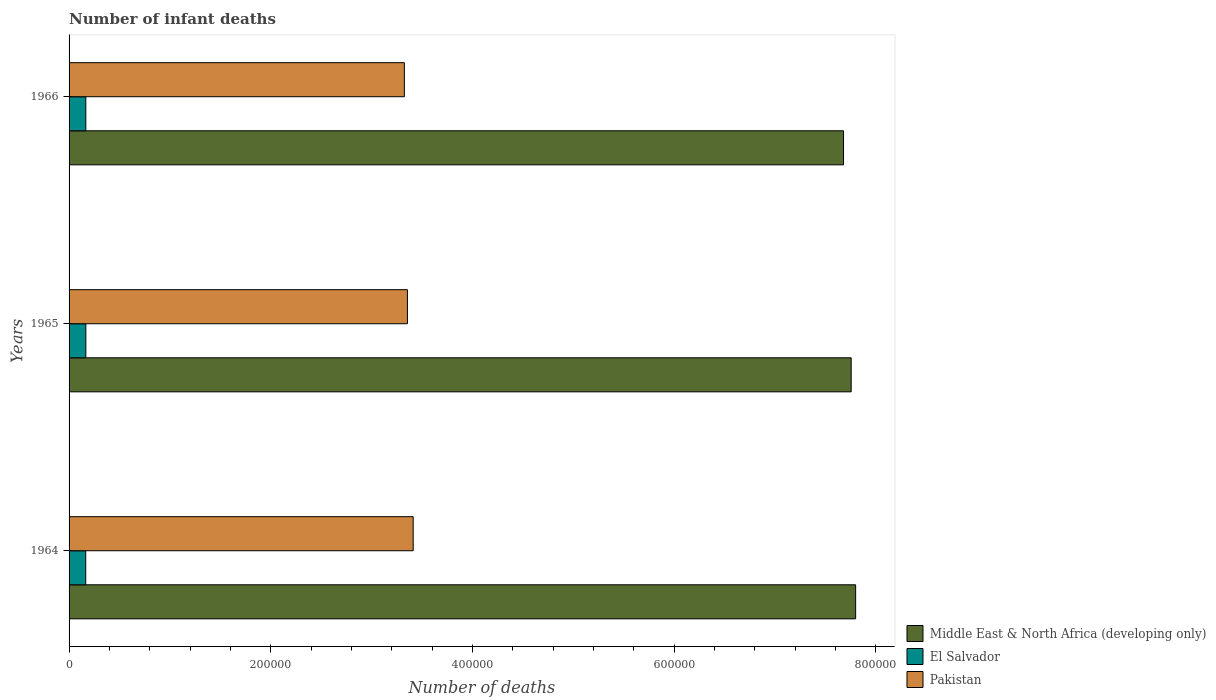How many groups of bars are there?
Give a very brief answer. 3. Are the number of bars per tick equal to the number of legend labels?
Offer a terse response. Yes. How many bars are there on the 2nd tick from the top?
Your answer should be compact. 3. How many bars are there on the 3rd tick from the bottom?
Offer a very short reply. 3. What is the label of the 2nd group of bars from the top?
Provide a short and direct response. 1965. What is the number of infant deaths in Middle East & North Africa (developing only) in 1965?
Ensure brevity in your answer.  7.75e+05. Across all years, what is the maximum number of infant deaths in Middle East & North Africa (developing only)?
Provide a succinct answer. 7.80e+05. Across all years, what is the minimum number of infant deaths in Pakistan?
Your response must be concise. 3.32e+05. In which year was the number of infant deaths in Pakistan maximum?
Make the answer very short. 1964. In which year was the number of infant deaths in El Salvador minimum?
Provide a succinct answer. 1964. What is the total number of infant deaths in Middle East & North Africa (developing only) in the graph?
Give a very brief answer. 2.32e+06. What is the difference between the number of infant deaths in Pakistan in 1965 and that in 1966?
Your answer should be very brief. 3063. What is the difference between the number of infant deaths in Pakistan in 1964 and the number of infant deaths in El Salvador in 1965?
Make the answer very short. 3.25e+05. What is the average number of infant deaths in Pakistan per year?
Provide a short and direct response. 3.36e+05. In the year 1964, what is the difference between the number of infant deaths in Middle East & North Africa (developing only) and number of infant deaths in Pakistan?
Your answer should be very brief. 4.39e+05. What is the ratio of the number of infant deaths in Pakistan in 1964 to that in 1966?
Your answer should be compact. 1.03. Is the difference between the number of infant deaths in Middle East & North Africa (developing only) in 1964 and 1965 greater than the difference between the number of infant deaths in Pakistan in 1964 and 1965?
Your answer should be very brief. No. What is the difference between the highest and the second highest number of infant deaths in Pakistan?
Offer a terse response. 5691. What is the difference between the highest and the lowest number of infant deaths in Pakistan?
Give a very brief answer. 8754. What does the 1st bar from the top in 1966 represents?
Make the answer very short. Pakistan. How many bars are there?
Ensure brevity in your answer.  9. Are all the bars in the graph horizontal?
Your response must be concise. Yes. How many years are there in the graph?
Provide a short and direct response. 3. Does the graph contain any zero values?
Make the answer very short. No. Where does the legend appear in the graph?
Provide a short and direct response. Bottom right. What is the title of the graph?
Provide a succinct answer. Number of infant deaths. Does "Sint Maarten (Dutch part)" appear as one of the legend labels in the graph?
Offer a very short reply. No. What is the label or title of the X-axis?
Your answer should be very brief. Number of deaths. What is the label or title of the Y-axis?
Offer a terse response. Years. What is the Number of deaths of Middle East & North Africa (developing only) in 1964?
Provide a short and direct response. 7.80e+05. What is the Number of deaths in El Salvador in 1964?
Offer a terse response. 1.65e+04. What is the Number of deaths of Pakistan in 1964?
Provide a short and direct response. 3.41e+05. What is the Number of deaths in Middle East & North Africa (developing only) in 1965?
Offer a terse response. 7.75e+05. What is the Number of deaths of El Salvador in 1965?
Your answer should be very brief. 1.66e+04. What is the Number of deaths in Pakistan in 1965?
Give a very brief answer. 3.35e+05. What is the Number of deaths in Middle East & North Africa (developing only) in 1966?
Your response must be concise. 7.68e+05. What is the Number of deaths of El Salvador in 1966?
Make the answer very short. 1.66e+04. What is the Number of deaths in Pakistan in 1966?
Make the answer very short. 3.32e+05. Across all years, what is the maximum Number of deaths in Middle East & North Africa (developing only)?
Make the answer very short. 7.80e+05. Across all years, what is the maximum Number of deaths in El Salvador?
Provide a short and direct response. 1.66e+04. Across all years, what is the maximum Number of deaths in Pakistan?
Provide a short and direct response. 3.41e+05. Across all years, what is the minimum Number of deaths of Middle East & North Africa (developing only)?
Offer a very short reply. 7.68e+05. Across all years, what is the minimum Number of deaths of El Salvador?
Your answer should be compact. 1.65e+04. Across all years, what is the minimum Number of deaths of Pakistan?
Your response must be concise. 3.32e+05. What is the total Number of deaths in Middle East & North Africa (developing only) in the graph?
Offer a very short reply. 2.32e+06. What is the total Number of deaths of El Salvador in the graph?
Your answer should be very brief. 4.97e+04. What is the total Number of deaths in Pakistan in the graph?
Your answer should be very brief. 1.01e+06. What is the difference between the Number of deaths of Middle East & North Africa (developing only) in 1964 and that in 1965?
Your answer should be very brief. 4438. What is the difference between the Number of deaths of El Salvador in 1964 and that in 1965?
Provide a short and direct response. -124. What is the difference between the Number of deaths of Pakistan in 1964 and that in 1965?
Make the answer very short. 5691. What is the difference between the Number of deaths of Middle East & North Africa (developing only) in 1964 and that in 1966?
Provide a short and direct response. 1.20e+04. What is the difference between the Number of deaths in El Salvador in 1964 and that in 1966?
Give a very brief answer. -102. What is the difference between the Number of deaths in Pakistan in 1964 and that in 1966?
Keep it short and to the point. 8754. What is the difference between the Number of deaths in Middle East & North Africa (developing only) in 1965 and that in 1966?
Offer a very short reply. 7578. What is the difference between the Number of deaths in El Salvador in 1965 and that in 1966?
Give a very brief answer. 22. What is the difference between the Number of deaths in Pakistan in 1965 and that in 1966?
Your response must be concise. 3063. What is the difference between the Number of deaths of Middle East & North Africa (developing only) in 1964 and the Number of deaths of El Salvador in 1965?
Offer a very short reply. 7.63e+05. What is the difference between the Number of deaths in Middle East & North Africa (developing only) in 1964 and the Number of deaths in Pakistan in 1965?
Give a very brief answer. 4.44e+05. What is the difference between the Number of deaths of El Salvador in 1964 and the Number of deaths of Pakistan in 1965?
Ensure brevity in your answer.  -3.19e+05. What is the difference between the Number of deaths in Middle East & North Africa (developing only) in 1964 and the Number of deaths in El Salvador in 1966?
Offer a terse response. 7.63e+05. What is the difference between the Number of deaths of Middle East & North Africa (developing only) in 1964 and the Number of deaths of Pakistan in 1966?
Offer a terse response. 4.47e+05. What is the difference between the Number of deaths of El Salvador in 1964 and the Number of deaths of Pakistan in 1966?
Your answer should be compact. -3.16e+05. What is the difference between the Number of deaths of Middle East & North Africa (developing only) in 1965 and the Number of deaths of El Salvador in 1966?
Provide a succinct answer. 7.59e+05. What is the difference between the Number of deaths in Middle East & North Africa (developing only) in 1965 and the Number of deaths in Pakistan in 1966?
Provide a succinct answer. 4.43e+05. What is the difference between the Number of deaths in El Salvador in 1965 and the Number of deaths in Pakistan in 1966?
Provide a succinct answer. -3.16e+05. What is the average Number of deaths of Middle East & North Africa (developing only) per year?
Give a very brief answer. 7.74e+05. What is the average Number of deaths of El Salvador per year?
Your response must be concise. 1.66e+04. What is the average Number of deaths of Pakistan per year?
Offer a very short reply. 3.36e+05. In the year 1964, what is the difference between the Number of deaths in Middle East & North Africa (developing only) and Number of deaths in El Salvador?
Your answer should be very brief. 7.63e+05. In the year 1964, what is the difference between the Number of deaths in Middle East & North Africa (developing only) and Number of deaths in Pakistan?
Provide a short and direct response. 4.39e+05. In the year 1964, what is the difference between the Number of deaths of El Salvador and Number of deaths of Pakistan?
Make the answer very short. -3.25e+05. In the year 1965, what is the difference between the Number of deaths in Middle East & North Africa (developing only) and Number of deaths in El Salvador?
Your answer should be compact. 7.59e+05. In the year 1965, what is the difference between the Number of deaths in Middle East & North Africa (developing only) and Number of deaths in Pakistan?
Your answer should be compact. 4.40e+05. In the year 1965, what is the difference between the Number of deaths in El Salvador and Number of deaths in Pakistan?
Keep it short and to the point. -3.19e+05. In the year 1966, what is the difference between the Number of deaths of Middle East & North Africa (developing only) and Number of deaths of El Salvador?
Your answer should be compact. 7.51e+05. In the year 1966, what is the difference between the Number of deaths of Middle East & North Africa (developing only) and Number of deaths of Pakistan?
Your answer should be compact. 4.35e+05. In the year 1966, what is the difference between the Number of deaths of El Salvador and Number of deaths of Pakistan?
Ensure brevity in your answer.  -3.16e+05. What is the ratio of the Number of deaths of Middle East & North Africa (developing only) in 1964 to that in 1965?
Make the answer very short. 1.01. What is the ratio of the Number of deaths in El Salvador in 1964 to that in 1965?
Offer a very short reply. 0.99. What is the ratio of the Number of deaths of Middle East & North Africa (developing only) in 1964 to that in 1966?
Give a very brief answer. 1.02. What is the ratio of the Number of deaths of Pakistan in 1964 to that in 1966?
Give a very brief answer. 1.03. What is the ratio of the Number of deaths of Middle East & North Africa (developing only) in 1965 to that in 1966?
Give a very brief answer. 1.01. What is the ratio of the Number of deaths of Pakistan in 1965 to that in 1966?
Make the answer very short. 1.01. What is the difference between the highest and the second highest Number of deaths in Middle East & North Africa (developing only)?
Offer a very short reply. 4438. What is the difference between the highest and the second highest Number of deaths of El Salvador?
Give a very brief answer. 22. What is the difference between the highest and the second highest Number of deaths of Pakistan?
Your response must be concise. 5691. What is the difference between the highest and the lowest Number of deaths in Middle East & North Africa (developing only)?
Ensure brevity in your answer.  1.20e+04. What is the difference between the highest and the lowest Number of deaths in El Salvador?
Offer a very short reply. 124. What is the difference between the highest and the lowest Number of deaths of Pakistan?
Your response must be concise. 8754. 